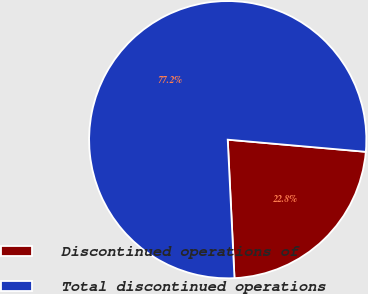Convert chart to OTSL. <chart><loc_0><loc_0><loc_500><loc_500><pie_chart><fcel>Discontinued operations of<fcel>Total discontinued operations<nl><fcel>22.83%<fcel>77.17%<nl></chart> 